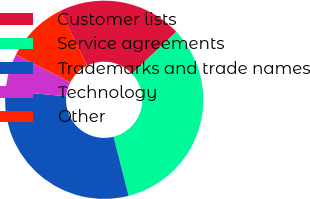<chart> <loc_0><loc_0><loc_500><loc_500><pie_chart><fcel>Customer lists<fcel>Service agreements<fcel>Trademarks and trade names<fcel>Technology<fcel>Other<nl><fcel>20.28%<fcel>33.06%<fcel>30.43%<fcel>6.09%<fcel>10.14%<nl></chart> 